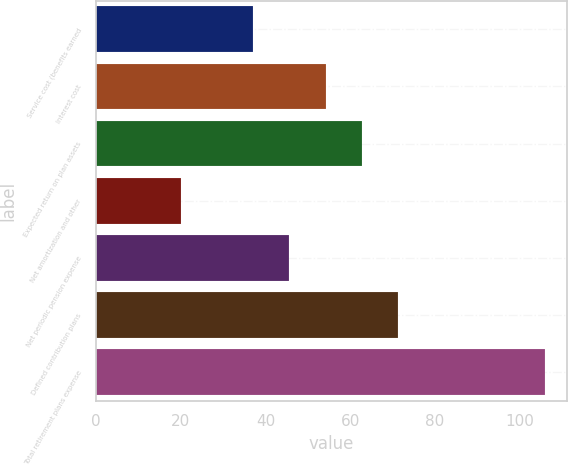Convert chart. <chart><loc_0><loc_0><loc_500><loc_500><bar_chart><fcel>Service cost (benefits earned<fcel>Interest cost<fcel>Expected return on plan assets<fcel>Net amortization and other<fcel>Net periodic pension expense<fcel>Defined contribution plans<fcel>Total retirement plans expense<nl><fcel>37<fcel>54.2<fcel>62.8<fcel>20<fcel>45.6<fcel>71.4<fcel>106<nl></chart> 